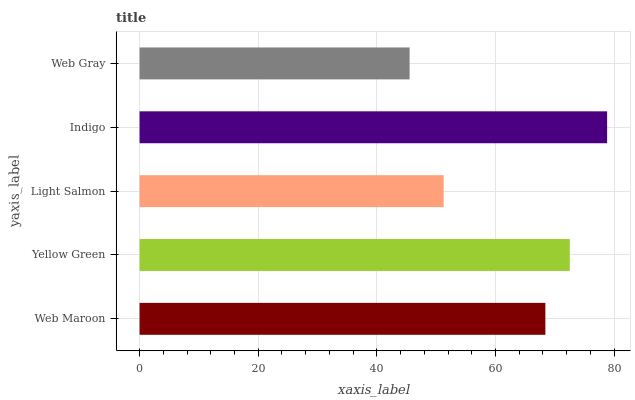Is Web Gray the minimum?
Answer yes or no. Yes. Is Indigo the maximum?
Answer yes or no. Yes. Is Yellow Green the minimum?
Answer yes or no. No. Is Yellow Green the maximum?
Answer yes or no. No. Is Yellow Green greater than Web Maroon?
Answer yes or no. Yes. Is Web Maroon less than Yellow Green?
Answer yes or no. Yes. Is Web Maroon greater than Yellow Green?
Answer yes or no. No. Is Yellow Green less than Web Maroon?
Answer yes or no. No. Is Web Maroon the high median?
Answer yes or no. Yes. Is Web Maroon the low median?
Answer yes or no. Yes. Is Web Gray the high median?
Answer yes or no. No. Is Web Gray the low median?
Answer yes or no. No. 